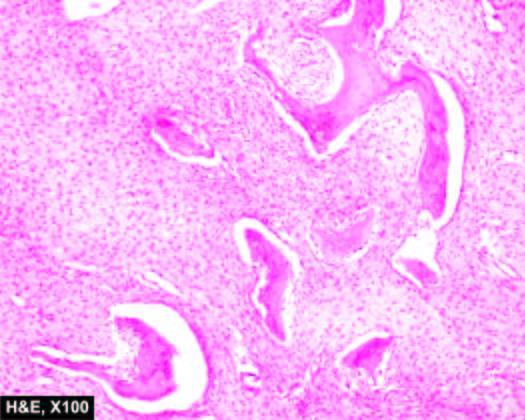re the osteoblastic rimming of the bony trabeculae characteristically absent?
Answer the question using a single word or phrase. Yes 